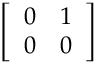Convert formula to latex. <formula><loc_0><loc_0><loc_500><loc_500>\left [ \begin{array} { l l } { 0 } & { 1 } \\ { 0 } & { 0 } \end{array} \right ]</formula> 